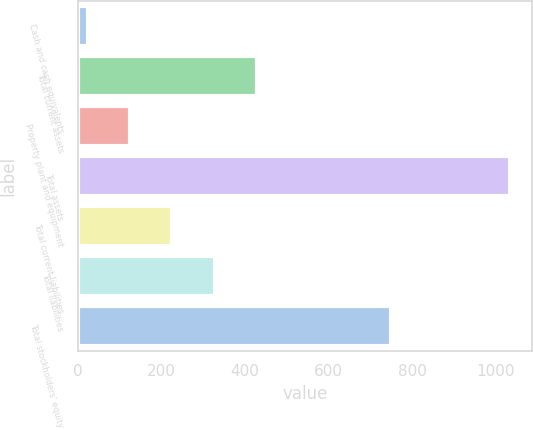Convert chart to OTSL. <chart><loc_0><loc_0><loc_500><loc_500><bar_chart><fcel>Cash and cash equivalents<fcel>Total current assets<fcel>Property plant and equipment<fcel>Total assets<fcel>Total current liabilities<fcel>Total liabilities<fcel>Total stockholders' equity<nl><fcel>23.6<fcel>429.6<fcel>124.69<fcel>1034.5<fcel>225.78<fcel>326.87<fcel>747.8<nl></chart> 